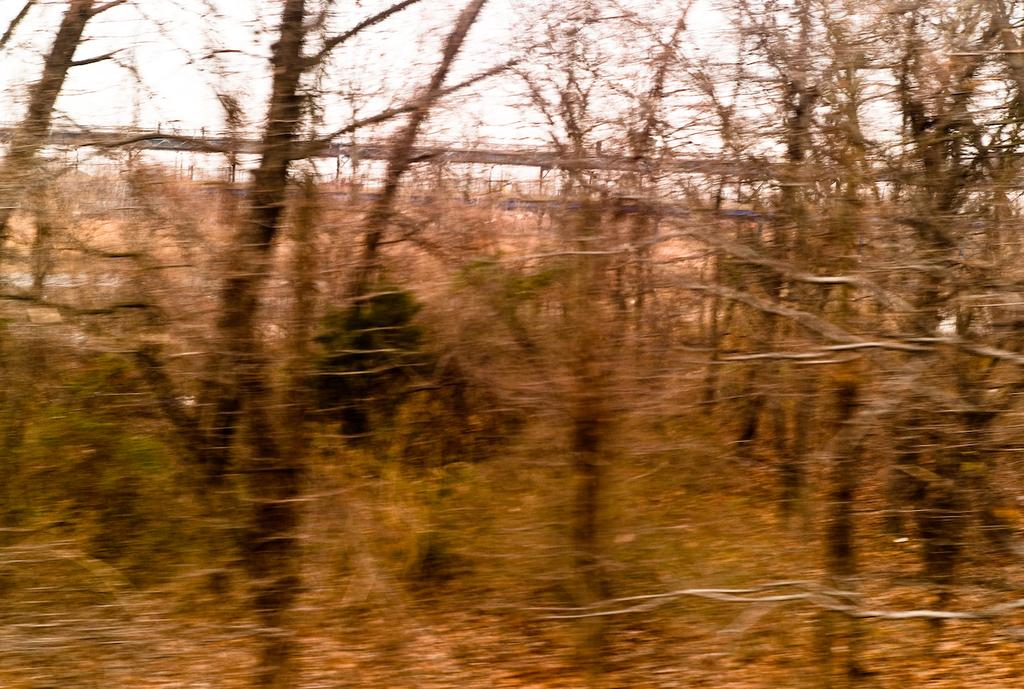What is the main subject in the center of the image? There are trees in the center of the image. What can be seen in the background of the image? There is a fence visible in the background of the image. What does the son say on the page in the image? There is no son or page present in the image; it only features trees and a fence. 